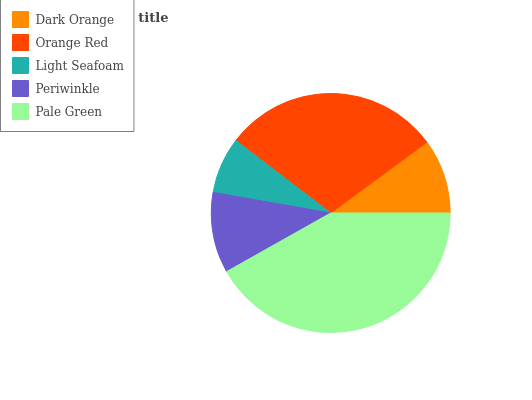Is Light Seafoam the minimum?
Answer yes or no. Yes. Is Pale Green the maximum?
Answer yes or no. Yes. Is Orange Red the minimum?
Answer yes or no. No. Is Orange Red the maximum?
Answer yes or no. No. Is Orange Red greater than Dark Orange?
Answer yes or no. Yes. Is Dark Orange less than Orange Red?
Answer yes or no. Yes. Is Dark Orange greater than Orange Red?
Answer yes or no. No. Is Orange Red less than Dark Orange?
Answer yes or no. No. Is Periwinkle the high median?
Answer yes or no. Yes. Is Periwinkle the low median?
Answer yes or no. Yes. Is Dark Orange the high median?
Answer yes or no. No. Is Light Seafoam the low median?
Answer yes or no. No. 